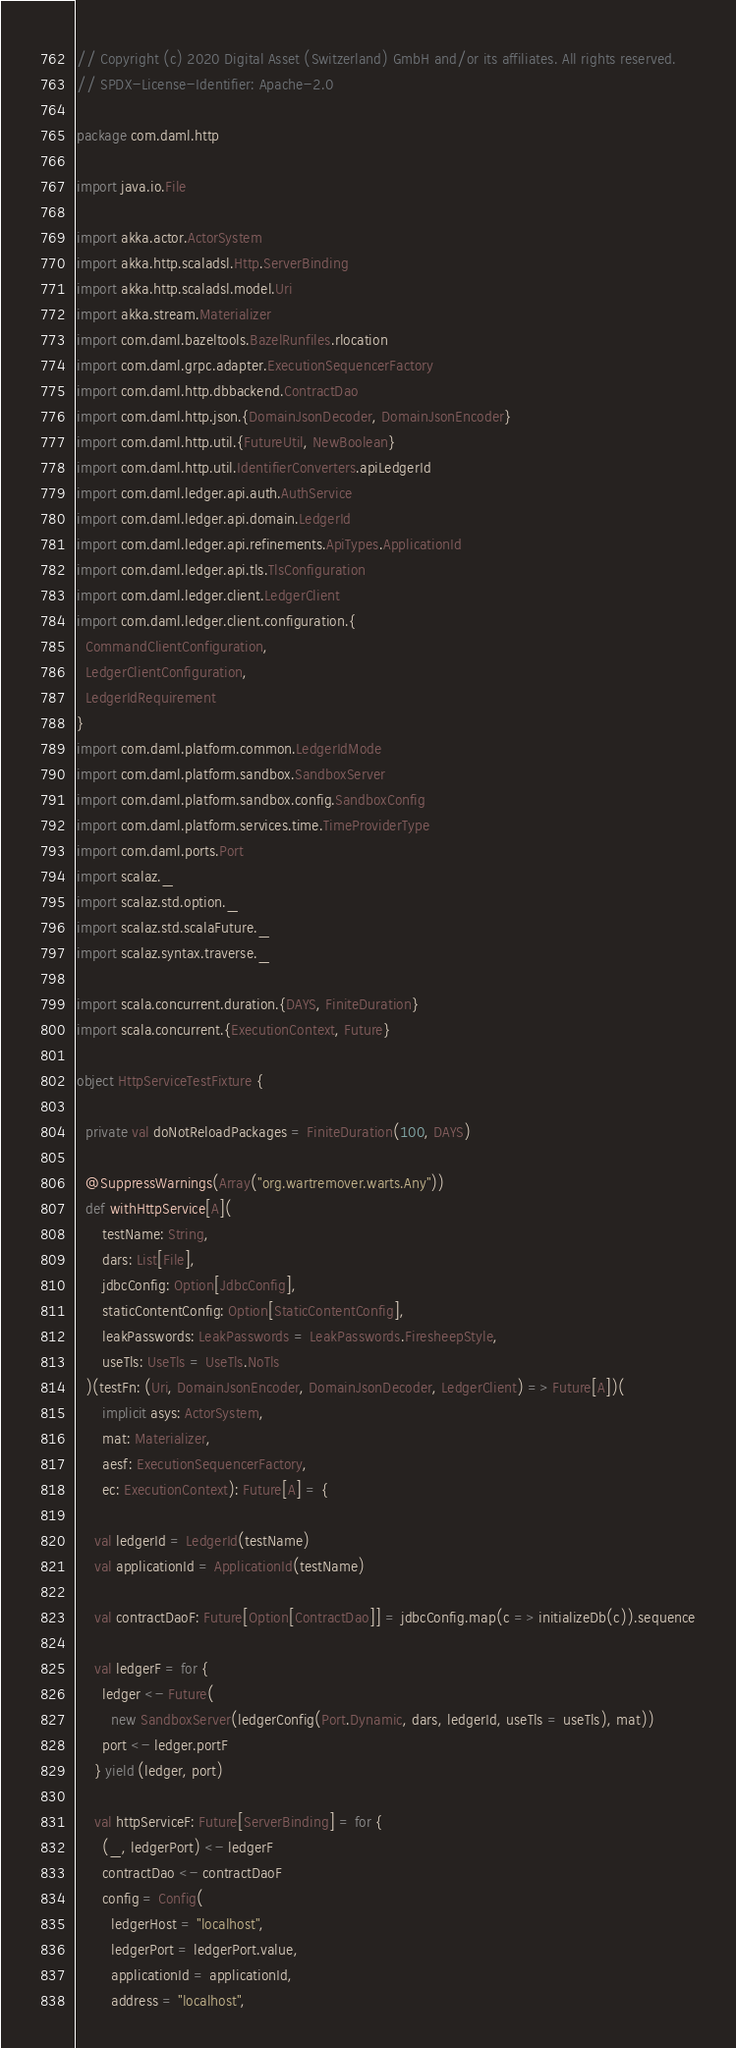Convert code to text. <code><loc_0><loc_0><loc_500><loc_500><_Scala_>// Copyright (c) 2020 Digital Asset (Switzerland) GmbH and/or its affiliates. All rights reserved.
// SPDX-License-Identifier: Apache-2.0

package com.daml.http

import java.io.File

import akka.actor.ActorSystem
import akka.http.scaladsl.Http.ServerBinding
import akka.http.scaladsl.model.Uri
import akka.stream.Materializer
import com.daml.bazeltools.BazelRunfiles.rlocation
import com.daml.grpc.adapter.ExecutionSequencerFactory
import com.daml.http.dbbackend.ContractDao
import com.daml.http.json.{DomainJsonDecoder, DomainJsonEncoder}
import com.daml.http.util.{FutureUtil, NewBoolean}
import com.daml.http.util.IdentifierConverters.apiLedgerId
import com.daml.ledger.api.auth.AuthService
import com.daml.ledger.api.domain.LedgerId
import com.daml.ledger.api.refinements.ApiTypes.ApplicationId
import com.daml.ledger.api.tls.TlsConfiguration
import com.daml.ledger.client.LedgerClient
import com.daml.ledger.client.configuration.{
  CommandClientConfiguration,
  LedgerClientConfiguration,
  LedgerIdRequirement
}
import com.daml.platform.common.LedgerIdMode
import com.daml.platform.sandbox.SandboxServer
import com.daml.platform.sandbox.config.SandboxConfig
import com.daml.platform.services.time.TimeProviderType
import com.daml.ports.Port
import scalaz._
import scalaz.std.option._
import scalaz.std.scalaFuture._
import scalaz.syntax.traverse._

import scala.concurrent.duration.{DAYS, FiniteDuration}
import scala.concurrent.{ExecutionContext, Future}

object HttpServiceTestFixture {

  private val doNotReloadPackages = FiniteDuration(100, DAYS)

  @SuppressWarnings(Array("org.wartremover.warts.Any"))
  def withHttpService[A](
      testName: String,
      dars: List[File],
      jdbcConfig: Option[JdbcConfig],
      staticContentConfig: Option[StaticContentConfig],
      leakPasswords: LeakPasswords = LeakPasswords.FiresheepStyle,
      useTls: UseTls = UseTls.NoTls
  )(testFn: (Uri, DomainJsonEncoder, DomainJsonDecoder, LedgerClient) => Future[A])(
      implicit asys: ActorSystem,
      mat: Materializer,
      aesf: ExecutionSequencerFactory,
      ec: ExecutionContext): Future[A] = {

    val ledgerId = LedgerId(testName)
    val applicationId = ApplicationId(testName)

    val contractDaoF: Future[Option[ContractDao]] = jdbcConfig.map(c => initializeDb(c)).sequence

    val ledgerF = for {
      ledger <- Future(
        new SandboxServer(ledgerConfig(Port.Dynamic, dars, ledgerId, useTls = useTls), mat))
      port <- ledger.portF
    } yield (ledger, port)

    val httpServiceF: Future[ServerBinding] = for {
      (_, ledgerPort) <- ledgerF
      contractDao <- contractDaoF
      config = Config(
        ledgerHost = "localhost",
        ledgerPort = ledgerPort.value,
        applicationId = applicationId,
        address = "localhost",</code> 